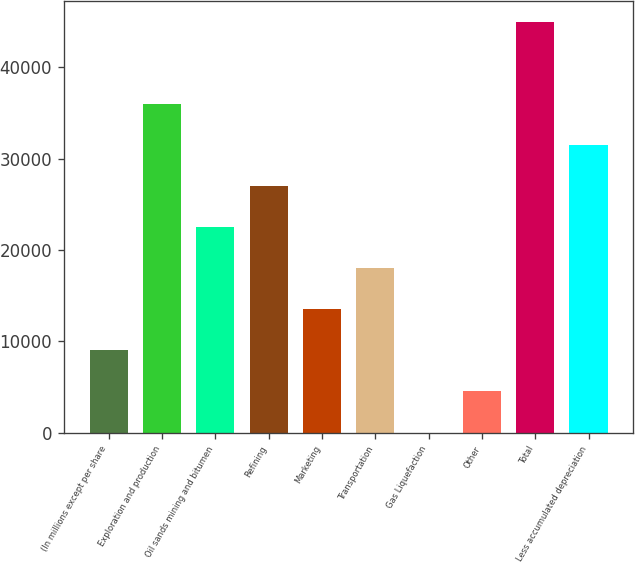Convert chart. <chart><loc_0><loc_0><loc_500><loc_500><bar_chart><fcel>(In millions except per share<fcel>Exploration and production<fcel>Oil sands mining and bitumen<fcel>Refining<fcel>Marketing<fcel>Transportation<fcel>Gas Liquefaction<fcel>Other<fcel>Total<fcel>Less accumulated depreciation<nl><fcel>9019.8<fcel>36001.2<fcel>22510.5<fcel>27007.4<fcel>13516.7<fcel>18013.6<fcel>26<fcel>4522.9<fcel>44995<fcel>31504.3<nl></chart> 